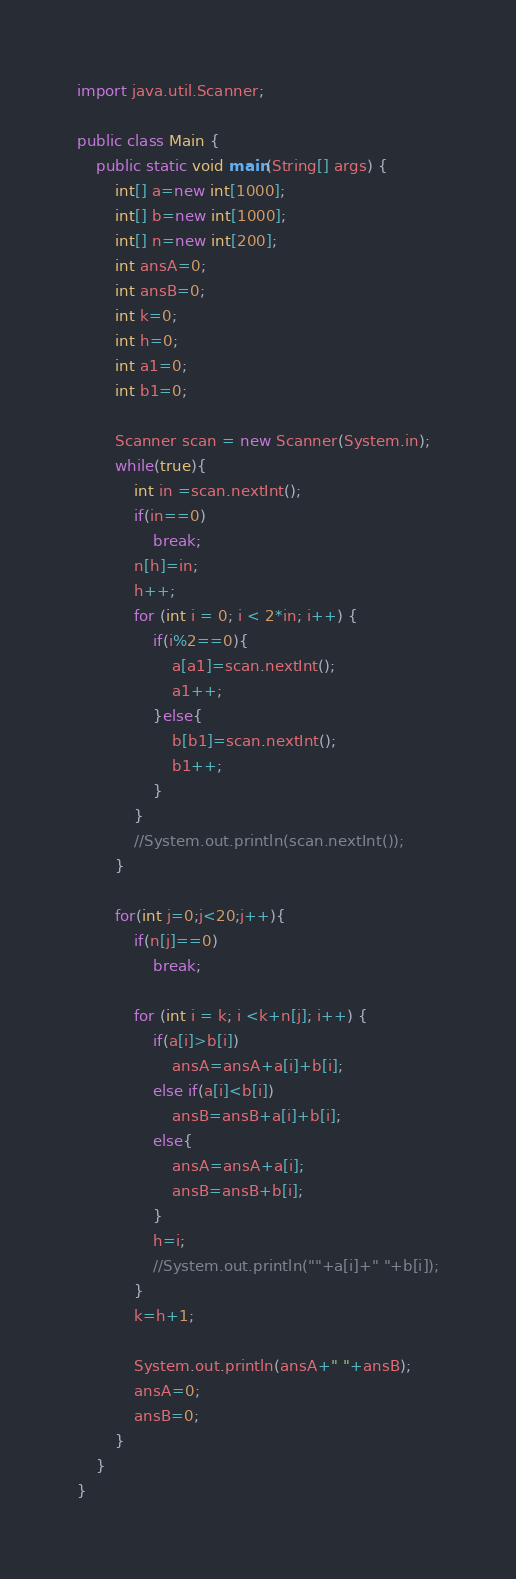Convert code to text. <code><loc_0><loc_0><loc_500><loc_500><_Java_>import java.util.Scanner;

public class Main {
	public static void main(String[] args) {
		int[] a=new int[1000];
		int[] b=new int[1000];
		int[] n=new int[200];
		int ansA=0;
		int ansB=0;
		int k=0;
		int h=0;
		int a1=0;
		int b1=0;
		
		Scanner scan = new Scanner(System.in);
		while(true){
			int in =scan.nextInt();
			if(in==0)
				break;
			n[h]=in;
			h++;
			for (int i = 0; i < 2*in; i++) {
				if(i%2==0){
					a[a1]=scan.nextInt();
					a1++;
				}else{
					b[b1]=scan.nextInt();
					b1++;
				}
			}
			//System.out.println(scan.nextInt());
		}
	
		for(int j=0;j<20;j++){
			if(n[j]==0)
				break;
			
			for (int i = k; i <k+n[j]; i++) {
				if(a[i]>b[i])
					ansA=ansA+a[i]+b[i];
				else if(a[i]<b[i])
					ansB=ansB+a[i]+b[i];
				else{	
					ansA=ansA+a[i];
					ansB=ansB+b[i];
				}
				h=i;
				//System.out.println(""+a[i]+" "+b[i]);
			}
			k=h+1;
			
			System.out.println(ansA+" "+ansB);
			ansA=0;
			ansB=0;
		}		
	}
}</code> 